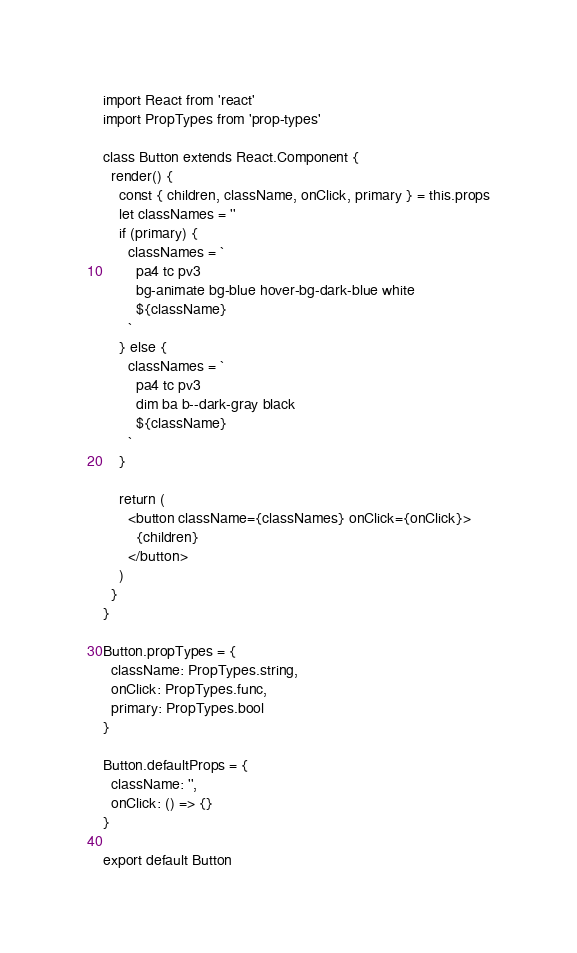<code> <loc_0><loc_0><loc_500><loc_500><_JavaScript_>import React from 'react'
import PropTypes from 'prop-types'

class Button extends React.Component {
  render() {
    const { children, className, onClick, primary } = this.props
    let classNames = ''
    if (primary) {
      classNames = `
        pa4 tc pv3
        bg-animate bg-blue hover-bg-dark-blue white
        ${className}
      `
    } else {
      classNames = `
        pa4 tc pv3
        dim ba b--dark-gray black
        ${className}
      `
    }

    return (
      <button className={classNames} onClick={onClick}>
        {children}
      </button>
    )
  }
}

Button.propTypes = {
  className: PropTypes.string,
  onClick: PropTypes.func,
  primary: PropTypes.bool
}

Button.defaultProps = {
  className: '',
  onClick: () => {}
}

export default Button
</code> 